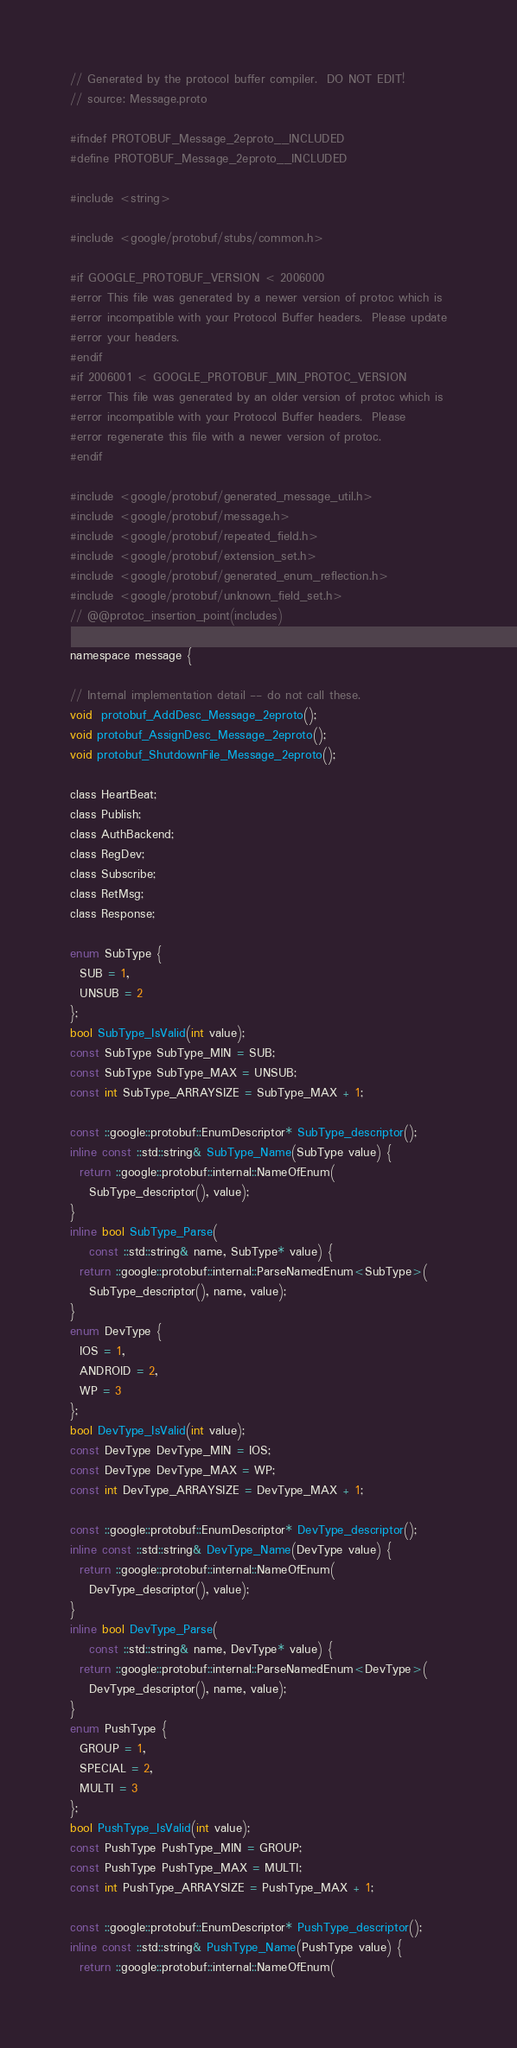<code> <loc_0><loc_0><loc_500><loc_500><_C_>// Generated by the protocol buffer compiler.  DO NOT EDIT!
// source: Message.proto

#ifndef PROTOBUF_Message_2eproto__INCLUDED
#define PROTOBUF_Message_2eproto__INCLUDED

#include <string>

#include <google/protobuf/stubs/common.h>

#if GOOGLE_PROTOBUF_VERSION < 2006000
#error This file was generated by a newer version of protoc which is
#error incompatible with your Protocol Buffer headers.  Please update
#error your headers.
#endif
#if 2006001 < GOOGLE_PROTOBUF_MIN_PROTOC_VERSION
#error This file was generated by an older version of protoc which is
#error incompatible with your Protocol Buffer headers.  Please
#error regenerate this file with a newer version of protoc.
#endif

#include <google/protobuf/generated_message_util.h>
#include <google/protobuf/message.h>
#include <google/protobuf/repeated_field.h>
#include <google/protobuf/extension_set.h>
#include <google/protobuf/generated_enum_reflection.h>
#include <google/protobuf/unknown_field_set.h>
// @@protoc_insertion_point(includes)

namespace message {

// Internal implementation detail -- do not call these.
void  protobuf_AddDesc_Message_2eproto();
void protobuf_AssignDesc_Message_2eproto();
void protobuf_ShutdownFile_Message_2eproto();

class HeartBeat;
class Publish;
class AuthBackend;
class RegDev;
class Subscribe;
class RetMsg;
class Response;

enum SubType {
  SUB = 1,
  UNSUB = 2
};
bool SubType_IsValid(int value);
const SubType SubType_MIN = SUB;
const SubType SubType_MAX = UNSUB;
const int SubType_ARRAYSIZE = SubType_MAX + 1;

const ::google::protobuf::EnumDescriptor* SubType_descriptor();
inline const ::std::string& SubType_Name(SubType value) {
  return ::google::protobuf::internal::NameOfEnum(
    SubType_descriptor(), value);
}
inline bool SubType_Parse(
    const ::std::string& name, SubType* value) {
  return ::google::protobuf::internal::ParseNamedEnum<SubType>(
    SubType_descriptor(), name, value);
}
enum DevType {
  IOS = 1,
  ANDROID = 2,
  WP = 3
};
bool DevType_IsValid(int value);
const DevType DevType_MIN = IOS;
const DevType DevType_MAX = WP;
const int DevType_ARRAYSIZE = DevType_MAX + 1;

const ::google::protobuf::EnumDescriptor* DevType_descriptor();
inline const ::std::string& DevType_Name(DevType value) {
  return ::google::protobuf::internal::NameOfEnum(
    DevType_descriptor(), value);
}
inline bool DevType_Parse(
    const ::std::string& name, DevType* value) {
  return ::google::protobuf::internal::ParseNamedEnum<DevType>(
    DevType_descriptor(), name, value);
}
enum PushType {
  GROUP = 1,
  SPECIAL = 2,
  MULTI = 3
};
bool PushType_IsValid(int value);
const PushType PushType_MIN = GROUP;
const PushType PushType_MAX = MULTI;
const int PushType_ARRAYSIZE = PushType_MAX + 1;

const ::google::protobuf::EnumDescriptor* PushType_descriptor();
inline const ::std::string& PushType_Name(PushType value) {
  return ::google::protobuf::internal::NameOfEnum(</code> 